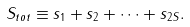<formula> <loc_0><loc_0><loc_500><loc_500>S _ { t o t } \equiv s _ { 1 } + s _ { 2 } + \cdots + s _ { 2 S } .</formula> 